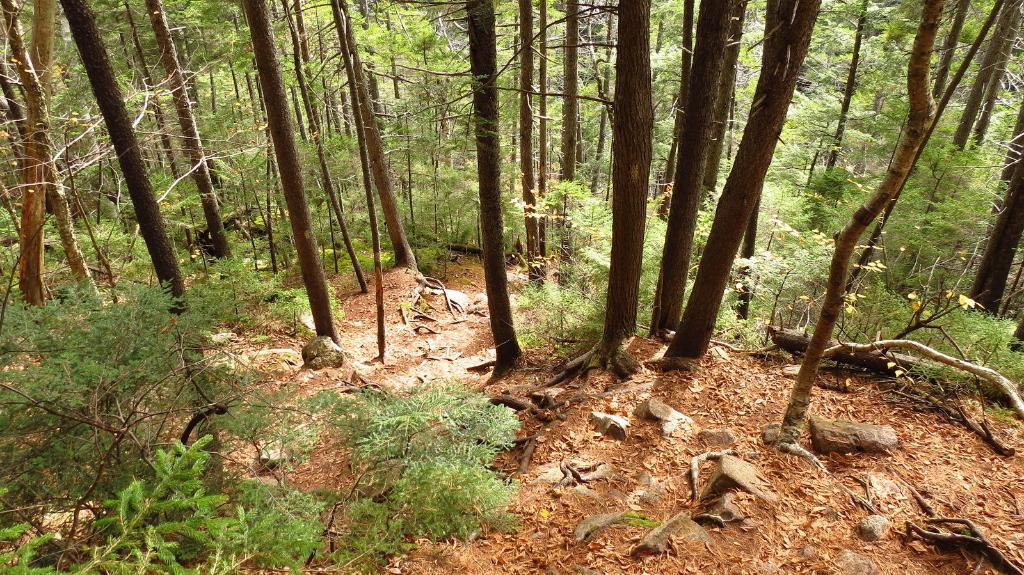What type of vegetation can be seen in the image? There are trees in the image. What is present on the surface at the bottom of the image? Dried leaves are present on the surface at the bottom of the image. What type of natural feature can be seen in the image? There are rocks in the image. What part of the trees is visible in the image? Branches of trees are visible in the image. Can you tell me the rate at which the owl is flying in the image? There is no owl present in the image, so it is not possible to determine the rate at which it might be flying. 